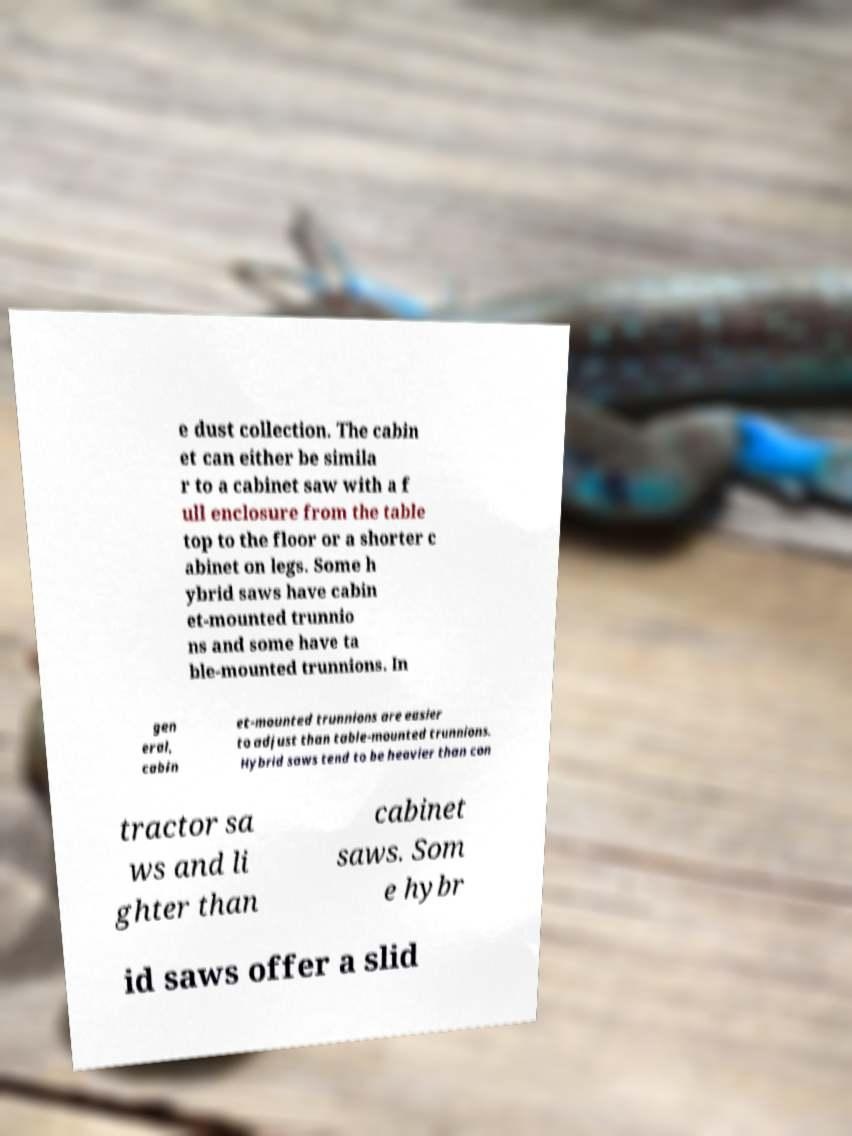Can you accurately transcribe the text from the provided image for me? e dust collection. The cabin et can either be simila r to a cabinet saw with a f ull enclosure from the table top to the floor or a shorter c abinet on legs. Some h ybrid saws have cabin et-mounted trunnio ns and some have ta ble-mounted trunnions. In gen eral, cabin et-mounted trunnions are easier to adjust than table-mounted trunnions. Hybrid saws tend to be heavier than con tractor sa ws and li ghter than cabinet saws. Som e hybr id saws offer a slid 